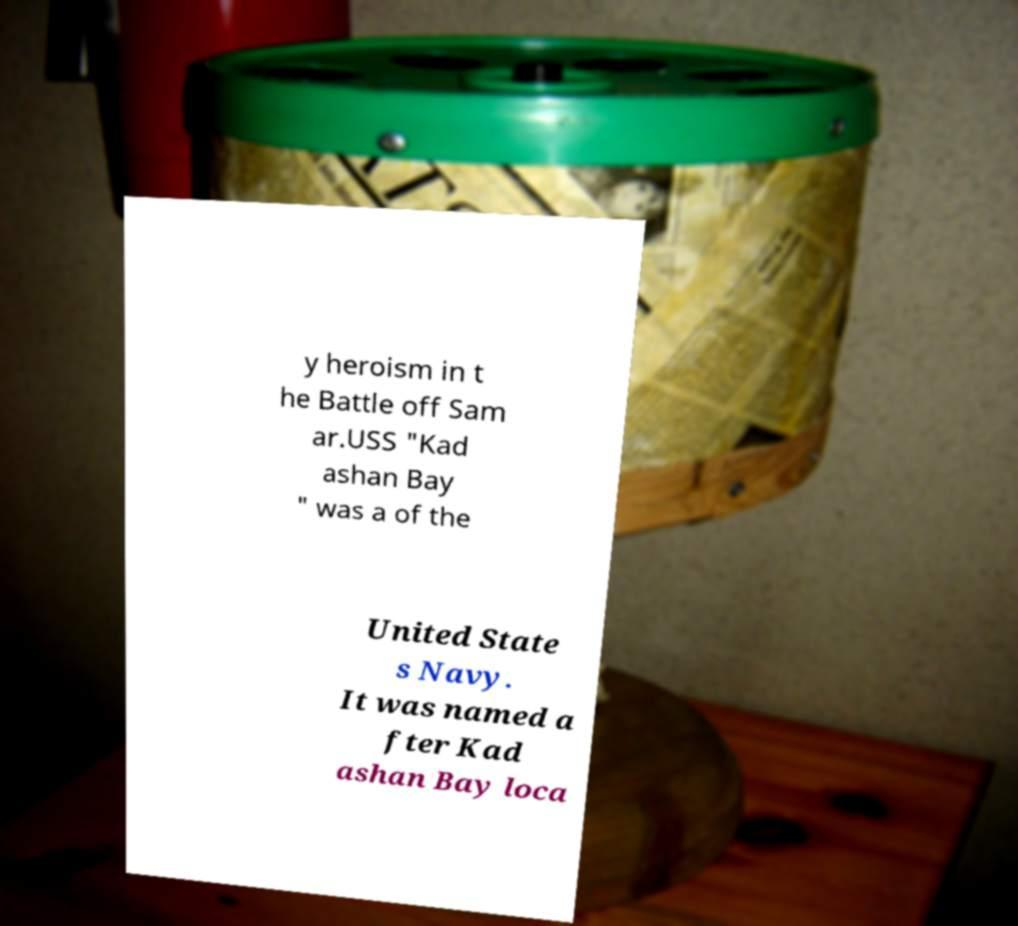Please identify and transcribe the text found in this image. y heroism in t he Battle off Sam ar.USS "Kad ashan Bay " was a of the United State s Navy. It was named a fter Kad ashan Bay loca 